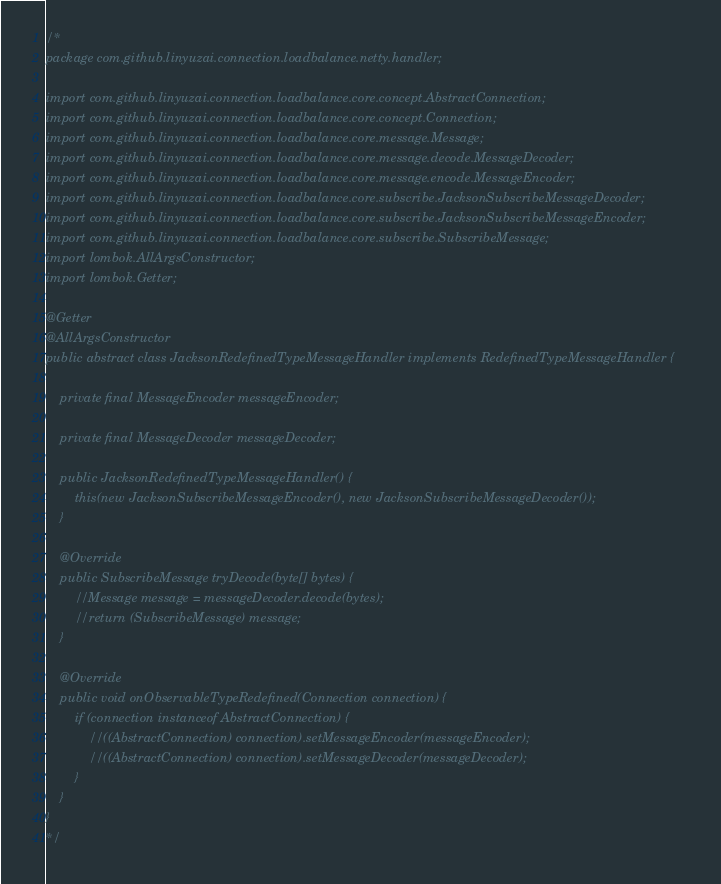Convert code to text. <code><loc_0><loc_0><loc_500><loc_500><_Java_>/*
package com.github.linyuzai.connection.loadbalance.netty.handler;

import com.github.linyuzai.connection.loadbalance.core.concept.AbstractConnection;
import com.github.linyuzai.connection.loadbalance.core.concept.Connection;
import com.github.linyuzai.connection.loadbalance.core.message.Message;
import com.github.linyuzai.connection.loadbalance.core.message.decode.MessageDecoder;
import com.github.linyuzai.connection.loadbalance.core.message.encode.MessageEncoder;
import com.github.linyuzai.connection.loadbalance.core.subscribe.JacksonSubscribeMessageDecoder;
import com.github.linyuzai.connection.loadbalance.core.subscribe.JacksonSubscribeMessageEncoder;
import com.github.linyuzai.connection.loadbalance.core.subscribe.SubscribeMessage;
import lombok.AllArgsConstructor;
import lombok.Getter;

@Getter
@AllArgsConstructor
public abstract class JacksonRedefinedTypeMessageHandler implements RedefinedTypeMessageHandler {

    private final MessageEncoder messageEncoder;

    private final MessageDecoder messageDecoder;

    public JacksonRedefinedTypeMessageHandler() {
        this(new JacksonSubscribeMessageEncoder(), new JacksonSubscribeMessageDecoder());
    }

    @Override
    public SubscribeMessage tryDecode(byte[] bytes) {
        //Message message = messageDecoder.decode(bytes);
        //return (SubscribeMessage) message;
    }

    @Override
    public void onObservableTypeRedefined(Connection connection) {
        if (connection instanceof AbstractConnection) {
            //((AbstractConnection) connection).setMessageEncoder(messageEncoder);
            //((AbstractConnection) connection).setMessageDecoder(messageDecoder);
        }
    }
}
*/
</code> 